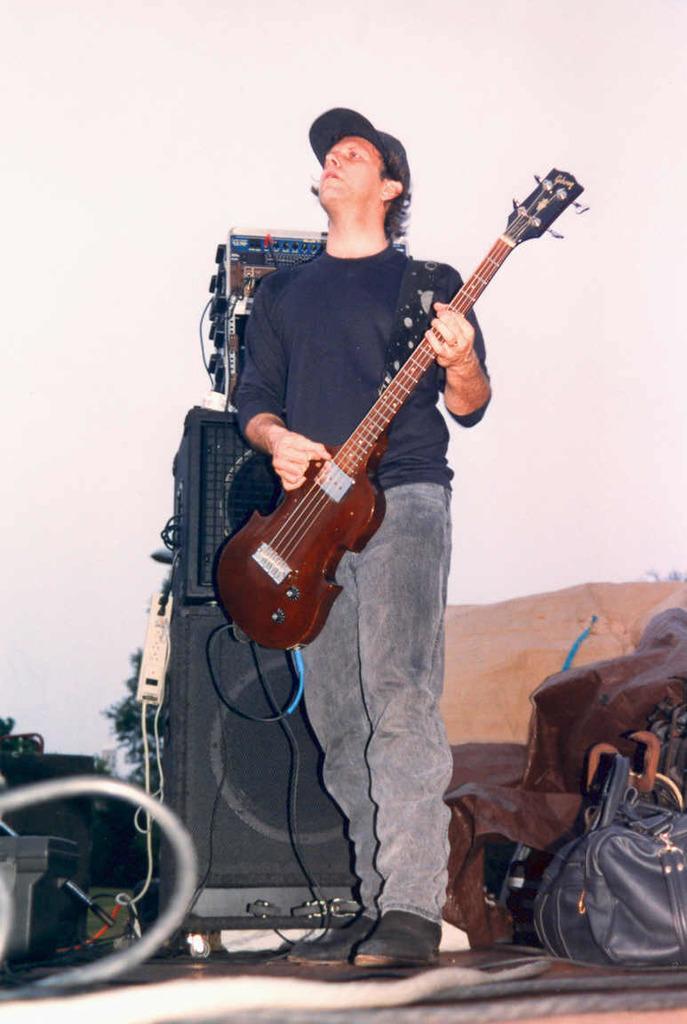Could you give a brief overview of what you see in this image? There is a person playing guitar and there is a sound box behind that and there is a bag. 